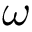Convert formula to latex. <formula><loc_0><loc_0><loc_500><loc_500>{ \boldsymbol \omega }</formula> 